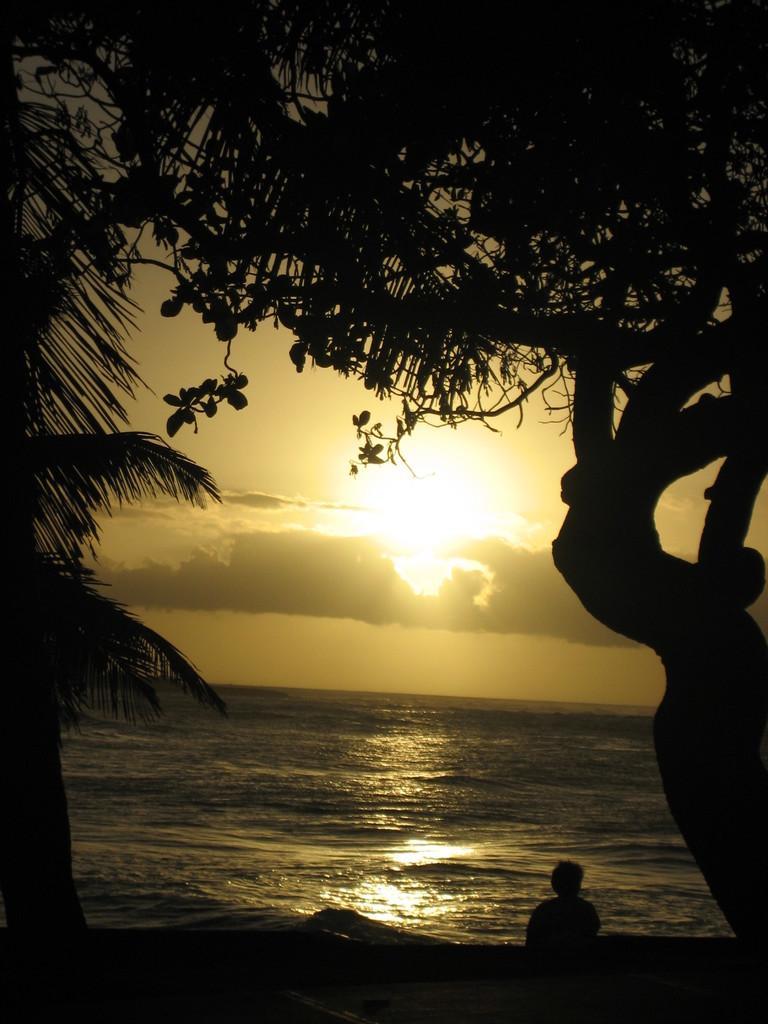Could you give a brief overview of what you see in this image? In this image at the bottom, there is a person. In the middle there are trees, water, sun, clouds and sky. 